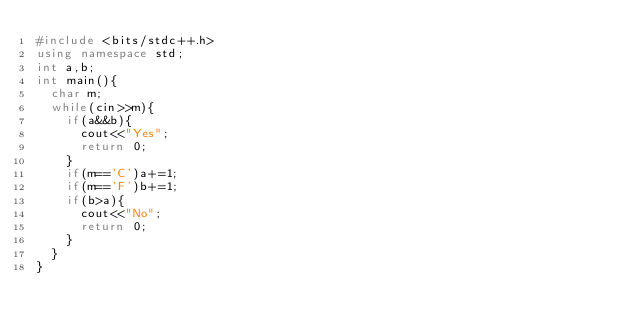<code> <loc_0><loc_0><loc_500><loc_500><_C++_>#include <bits/stdc++.h>
using namespace std;
int a,b;
int main(){
	char m;
	while(cin>>m){
		if(a&&b){
			cout<<"Yes";
			return 0;
		}
		if(m=='C')a+=1;
		if(m=='F')b+=1;
		if(b>a){
			cout<<"No";
			return 0; 
		}
	}
}</code> 